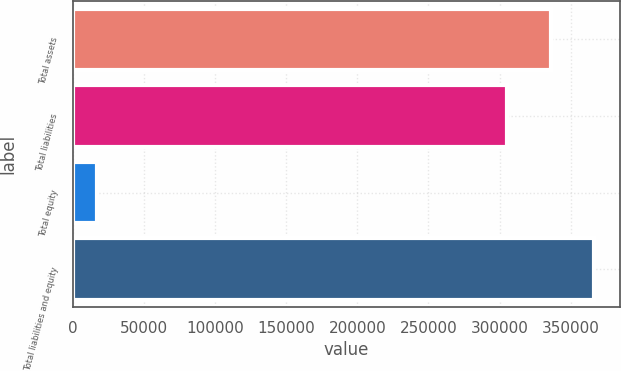Convert chart. <chart><loc_0><loc_0><loc_500><loc_500><bar_chart><fcel>Total assets<fcel>Total liabilities<fcel>Total equity<fcel>Total liabilities and equity<nl><fcel>336007<fcel>305461<fcel>16800<fcel>366553<nl></chart> 